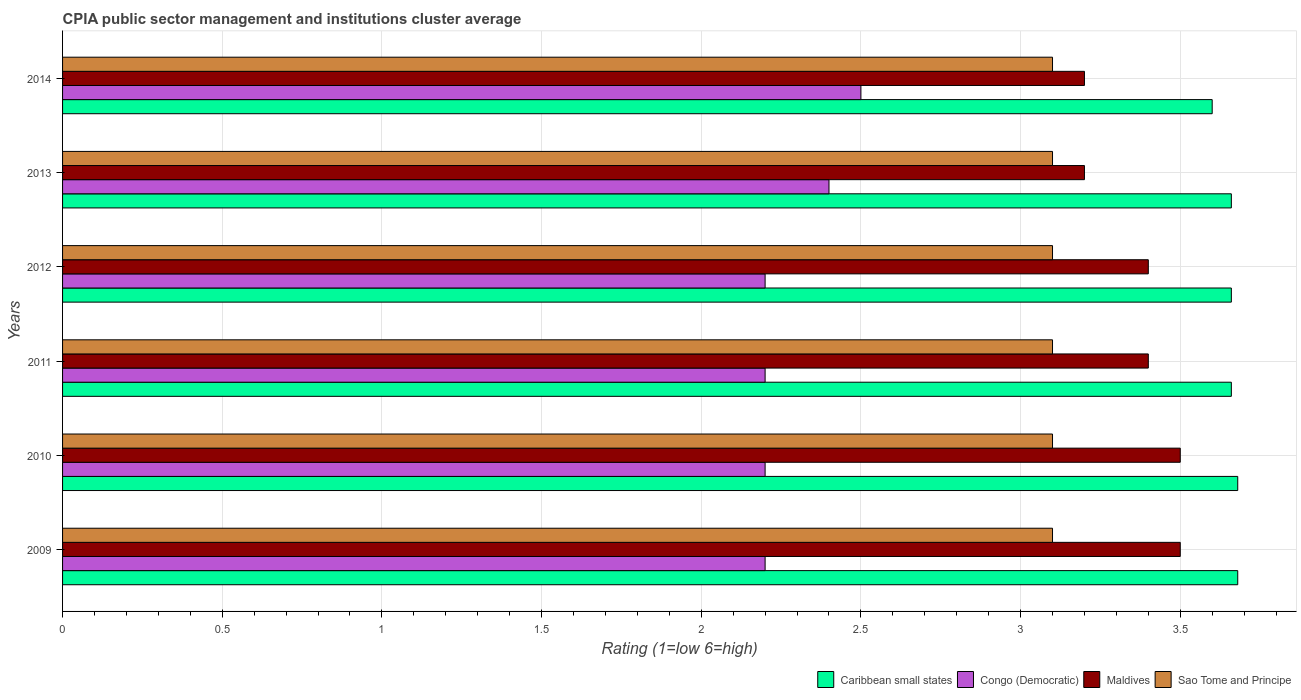Are the number of bars per tick equal to the number of legend labels?
Provide a succinct answer. Yes. How many bars are there on the 2nd tick from the top?
Your answer should be very brief. 4. In how many cases, is the number of bars for a given year not equal to the number of legend labels?
Give a very brief answer. 0. What is the CPIA rating in Caribbean small states in 2010?
Your response must be concise. 3.68. Across all years, what is the minimum CPIA rating in Congo (Democratic)?
Your answer should be very brief. 2.2. In which year was the CPIA rating in Sao Tome and Principe maximum?
Your answer should be compact. 2009. In which year was the CPIA rating in Maldives minimum?
Make the answer very short. 2013. What is the total CPIA rating in Sao Tome and Principe in the graph?
Offer a very short reply. 18.6. What is the difference between the CPIA rating in Caribbean small states in 2011 and that in 2012?
Offer a very short reply. 0. What is the difference between the CPIA rating in Maldives in 2009 and the CPIA rating in Caribbean small states in 2012?
Your response must be concise. -0.16. What is the average CPIA rating in Maldives per year?
Provide a succinct answer. 3.37. In the year 2009, what is the difference between the CPIA rating in Maldives and CPIA rating in Sao Tome and Principe?
Provide a succinct answer. 0.4. In how many years, is the CPIA rating in Maldives greater than 0.9 ?
Give a very brief answer. 6. What is the ratio of the CPIA rating in Maldives in 2010 to that in 2013?
Your response must be concise. 1.09. Is the CPIA rating in Sao Tome and Principe in 2012 less than that in 2014?
Offer a terse response. No. Is the difference between the CPIA rating in Maldives in 2009 and 2013 greater than the difference between the CPIA rating in Sao Tome and Principe in 2009 and 2013?
Your answer should be very brief. Yes. What is the difference between the highest and the lowest CPIA rating in Sao Tome and Principe?
Your answer should be compact. 0. In how many years, is the CPIA rating in Congo (Democratic) greater than the average CPIA rating in Congo (Democratic) taken over all years?
Offer a terse response. 2. Is the sum of the CPIA rating in Sao Tome and Principe in 2010 and 2011 greater than the maximum CPIA rating in Congo (Democratic) across all years?
Ensure brevity in your answer.  Yes. What does the 4th bar from the top in 2009 represents?
Your answer should be very brief. Caribbean small states. What does the 3rd bar from the bottom in 2009 represents?
Keep it short and to the point. Maldives. Is it the case that in every year, the sum of the CPIA rating in Caribbean small states and CPIA rating in Maldives is greater than the CPIA rating in Sao Tome and Principe?
Provide a succinct answer. Yes. How many years are there in the graph?
Keep it short and to the point. 6. What is the difference between two consecutive major ticks on the X-axis?
Keep it short and to the point. 0.5. Are the values on the major ticks of X-axis written in scientific E-notation?
Your answer should be compact. No. Does the graph contain any zero values?
Make the answer very short. No. How are the legend labels stacked?
Your answer should be compact. Horizontal. What is the title of the graph?
Offer a very short reply. CPIA public sector management and institutions cluster average. Does "Mozambique" appear as one of the legend labels in the graph?
Make the answer very short. No. What is the label or title of the X-axis?
Offer a terse response. Rating (1=low 6=high). What is the Rating (1=low 6=high) in Caribbean small states in 2009?
Offer a terse response. 3.68. What is the Rating (1=low 6=high) in Congo (Democratic) in 2009?
Keep it short and to the point. 2.2. What is the Rating (1=low 6=high) of Maldives in 2009?
Your response must be concise. 3.5. What is the Rating (1=low 6=high) in Caribbean small states in 2010?
Make the answer very short. 3.68. What is the Rating (1=low 6=high) in Maldives in 2010?
Provide a succinct answer. 3.5. What is the Rating (1=low 6=high) of Sao Tome and Principe in 2010?
Keep it short and to the point. 3.1. What is the Rating (1=low 6=high) of Caribbean small states in 2011?
Make the answer very short. 3.66. What is the Rating (1=low 6=high) of Congo (Democratic) in 2011?
Give a very brief answer. 2.2. What is the Rating (1=low 6=high) of Maldives in 2011?
Provide a short and direct response. 3.4. What is the Rating (1=low 6=high) of Caribbean small states in 2012?
Offer a terse response. 3.66. What is the Rating (1=low 6=high) of Congo (Democratic) in 2012?
Give a very brief answer. 2.2. What is the Rating (1=low 6=high) in Caribbean small states in 2013?
Your answer should be compact. 3.66. What is the Rating (1=low 6=high) of Congo (Democratic) in 2013?
Your answer should be very brief. 2.4. What is the Rating (1=low 6=high) of Congo (Democratic) in 2014?
Give a very brief answer. 2.5. What is the Rating (1=low 6=high) of Maldives in 2014?
Make the answer very short. 3.2. What is the Rating (1=low 6=high) in Sao Tome and Principe in 2014?
Your answer should be very brief. 3.1. Across all years, what is the maximum Rating (1=low 6=high) of Caribbean small states?
Provide a short and direct response. 3.68. Across all years, what is the maximum Rating (1=low 6=high) in Congo (Democratic)?
Ensure brevity in your answer.  2.5. Across all years, what is the maximum Rating (1=low 6=high) of Sao Tome and Principe?
Make the answer very short. 3.1. Across all years, what is the minimum Rating (1=low 6=high) of Congo (Democratic)?
Ensure brevity in your answer.  2.2. Across all years, what is the minimum Rating (1=low 6=high) in Maldives?
Make the answer very short. 3.2. Across all years, what is the minimum Rating (1=low 6=high) of Sao Tome and Principe?
Keep it short and to the point. 3.1. What is the total Rating (1=low 6=high) of Caribbean small states in the graph?
Offer a very short reply. 21.94. What is the total Rating (1=low 6=high) of Congo (Democratic) in the graph?
Your response must be concise. 13.7. What is the total Rating (1=low 6=high) in Maldives in the graph?
Your answer should be compact. 20.2. What is the difference between the Rating (1=low 6=high) of Caribbean small states in 2009 and that in 2010?
Make the answer very short. 0. What is the difference between the Rating (1=low 6=high) in Congo (Democratic) in 2009 and that in 2010?
Keep it short and to the point. 0. What is the difference between the Rating (1=low 6=high) of Maldives in 2009 and that in 2010?
Offer a terse response. 0. What is the difference between the Rating (1=low 6=high) in Sao Tome and Principe in 2009 and that in 2010?
Your response must be concise. 0. What is the difference between the Rating (1=low 6=high) of Maldives in 2009 and that in 2011?
Make the answer very short. 0.1. What is the difference between the Rating (1=low 6=high) in Congo (Democratic) in 2009 and that in 2012?
Provide a succinct answer. 0. What is the difference between the Rating (1=low 6=high) in Maldives in 2009 and that in 2013?
Provide a short and direct response. 0.3. What is the difference between the Rating (1=low 6=high) of Caribbean small states in 2009 and that in 2014?
Offer a very short reply. 0.08. What is the difference between the Rating (1=low 6=high) in Congo (Democratic) in 2009 and that in 2014?
Your response must be concise. -0.3. What is the difference between the Rating (1=low 6=high) in Maldives in 2009 and that in 2014?
Offer a very short reply. 0.3. What is the difference between the Rating (1=low 6=high) of Congo (Democratic) in 2010 and that in 2011?
Offer a very short reply. 0. What is the difference between the Rating (1=low 6=high) of Sao Tome and Principe in 2010 and that in 2011?
Give a very brief answer. 0. What is the difference between the Rating (1=low 6=high) in Caribbean small states in 2010 and that in 2013?
Give a very brief answer. 0.02. What is the difference between the Rating (1=low 6=high) in Congo (Democratic) in 2010 and that in 2013?
Offer a terse response. -0.2. What is the difference between the Rating (1=low 6=high) of Maldives in 2010 and that in 2013?
Provide a short and direct response. 0.3. What is the difference between the Rating (1=low 6=high) in Caribbean small states in 2010 and that in 2014?
Your answer should be very brief. 0.08. What is the difference between the Rating (1=low 6=high) of Maldives in 2010 and that in 2014?
Your answer should be compact. 0.3. What is the difference between the Rating (1=low 6=high) of Sao Tome and Principe in 2010 and that in 2014?
Keep it short and to the point. 0. What is the difference between the Rating (1=low 6=high) in Congo (Democratic) in 2011 and that in 2013?
Provide a succinct answer. -0.2. What is the difference between the Rating (1=low 6=high) in Caribbean small states in 2011 and that in 2014?
Your answer should be compact. 0.06. What is the difference between the Rating (1=low 6=high) in Congo (Democratic) in 2011 and that in 2014?
Give a very brief answer. -0.3. What is the difference between the Rating (1=low 6=high) in Maldives in 2011 and that in 2014?
Give a very brief answer. 0.2. What is the difference between the Rating (1=low 6=high) in Caribbean small states in 2012 and that in 2013?
Keep it short and to the point. 0. What is the difference between the Rating (1=low 6=high) in Sao Tome and Principe in 2012 and that in 2013?
Your answer should be very brief. 0. What is the difference between the Rating (1=low 6=high) of Caribbean small states in 2012 and that in 2014?
Give a very brief answer. 0.06. What is the difference between the Rating (1=low 6=high) in Congo (Democratic) in 2012 and that in 2014?
Ensure brevity in your answer.  -0.3. What is the difference between the Rating (1=low 6=high) in Maldives in 2012 and that in 2014?
Offer a terse response. 0.2. What is the difference between the Rating (1=low 6=high) in Caribbean small states in 2013 and that in 2014?
Your response must be concise. 0.06. What is the difference between the Rating (1=low 6=high) of Caribbean small states in 2009 and the Rating (1=low 6=high) of Congo (Democratic) in 2010?
Provide a succinct answer. 1.48. What is the difference between the Rating (1=low 6=high) in Caribbean small states in 2009 and the Rating (1=low 6=high) in Maldives in 2010?
Your answer should be very brief. 0.18. What is the difference between the Rating (1=low 6=high) in Caribbean small states in 2009 and the Rating (1=low 6=high) in Sao Tome and Principe in 2010?
Your answer should be very brief. 0.58. What is the difference between the Rating (1=low 6=high) of Congo (Democratic) in 2009 and the Rating (1=low 6=high) of Maldives in 2010?
Your answer should be compact. -1.3. What is the difference between the Rating (1=low 6=high) in Congo (Democratic) in 2009 and the Rating (1=low 6=high) in Sao Tome and Principe in 2010?
Offer a very short reply. -0.9. What is the difference between the Rating (1=low 6=high) of Caribbean small states in 2009 and the Rating (1=low 6=high) of Congo (Democratic) in 2011?
Provide a short and direct response. 1.48. What is the difference between the Rating (1=low 6=high) in Caribbean small states in 2009 and the Rating (1=low 6=high) in Maldives in 2011?
Make the answer very short. 0.28. What is the difference between the Rating (1=low 6=high) of Caribbean small states in 2009 and the Rating (1=low 6=high) of Sao Tome and Principe in 2011?
Offer a terse response. 0.58. What is the difference between the Rating (1=low 6=high) of Congo (Democratic) in 2009 and the Rating (1=low 6=high) of Maldives in 2011?
Provide a succinct answer. -1.2. What is the difference between the Rating (1=low 6=high) in Caribbean small states in 2009 and the Rating (1=low 6=high) in Congo (Democratic) in 2012?
Your response must be concise. 1.48. What is the difference between the Rating (1=low 6=high) of Caribbean small states in 2009 and the Rating (1=low 6=high) of Maldives in 2012?
Give a very brief answer. 0.28. What is the difference between the Rating (1=low 6=high) in Caribbean small states in 2009 and the Rating (1=low 6=high) in Sao Tome and Principe in 2012?
Keep it short and to the point. 0.58. What is the difference between the Rating (1=low 6=high) of Caribbean small states in 2009 and the Rating (1=low 6=high) of Congo (Democratic) in 2013?
Make the answer very short. 1.28. What is the difference between the Rating (1=low 6=high) in Caribbean small states in 2009 and the Rating (1=low 6=high) in Maldives in 2013?
Offer a very short reply. 0.48. What is the difference between the Rating (1=low 6=high) in Caribbean small states in 2009 and the Rating (1=low 6=high) in Sao Tome and Principe in 2013?
Provide a succinct answer. 0.58. What is the difference between the Rating (1=low 6=high) in Congo (Democratic) in 2009 and the Rating (1=low 6=high) in Maldives in 2013?
Provide a short and direct response. -1. What is the difference between the Rating (1=low 6=high) of Congo (Democratic) in 2009 and the Rating (1=low 6=high) of Sao Tome and Principe in 2013?
Your answer should be very brief. -0.9. What is the difference between the Rating (1=low 6=high) of Caribbean small states in 2009 and the Rating (1=low 6=high) of Congo (Democratic) in 2014?
Your answer should be very brief. 1.18. What is the difference between the Rating (1=low 6=high) in Caribbean small states in 2009 and the Rating (1=low 6=high) in Maldives in 2014?
Give a very brief answer. 0.48. What is the difference between the Rating (1=low 6=high) in Caribbean small states in 2009 and the Rating (1=low 6=high) in Sao Tome and Principe in 2014?
Make the answer very short. 0.58. What is the difference between the Rating (1=low 6=high) of Maldives in 2009 and the Rating (1=low 6=high) of Sao Tome and Principe in 2014?
Offer a terse response. 0.4. What is the difference between the Rating (1=low 6=high) in Caribbean small states in 2010 and the Rating (1=low 6=high) in Congo (Democratic) in 2011?
Ensure brevity in your answer.  1.48. What is the difference between the Rating (1=low 6=high) in Caribbean small states in 2010 and the Rating (1=low 6=high) in Maldives in 2011?
Provide a succinct answer. 0.28. What is the difference between the Rating (1=low 6=high) of Caribbean small states in 2010 and the Rating (1=low 6=high) of Sao Tome and Principe in 2011?
Make the answer very short. 0.58. What is the difference between the Rating (1=low 6=high) in Maldives in 2010 and the Rating (1=low 6=high) in Sao Tome and Principe in 2011?
Offer a terse response. 0.4. What is the difference between the Rating (1=low 6=high) of Caribbean small states in 2010 and the Rating (1=low 6=high) of Congo (Democratic) in 2012?
Make the answer very short. 1.48. What is the difference between the Rating (1=low 6=high) in Caribbean small states in 2010 and the Rating (1=low 6=high) in Maldives in 2012?
Provide a succinct answer. 0.28. What is the difference between the Rating (1=low 6=high) of Caribbean small states in 2010 and the Rating (1=low 6=high) of Sao Tome and Principe in 2012?
Give a very brief answer. 0.58. What is the difference between the Rating (1=low 6=high) in Congo (Democratic) in 2010 and the Rating (1=low 6=high) in Maldives in 2012?
Offer a terse response. -1.2. What is the difference between the Rating (1=low 6=high) of Caribbean small states in 2010 and the Rating (1=low 6=high) of Congo (Democratic) in 2013?
Keep it short and to the point. 1.28. What is the difference between the Rating (1=low 6=high) of Caribbean small states in 2010 and the Rating (1=low 6=high) of Maldives in 2013?
Make the answer very short. 0.48. What is the difference between the Rating (1=low 6=high) of Caribbean small states in 2010 and the Rating (1=low 6=high) of Sao Tome and Principe in 2013?
Make the answer very short. 0.58. What is the difference between the Rating (1=low 6=high) of Congo (Democratic) in 2010 and the Rating (1=low 6=high) of Maldives in 2013?
Offer a very short reply. -1. What is the difference between the Rating (1=low 6=high) of Maldives in 2010 and the Rating (1=low 6=high) of Sao Tome and Principe in 2013?
Offer a terse response. 0.4. What is the difference between the Rating (1=low 6=high) in Caribbean small states in 2010 and the Rating (1=low 6=high) in Congo (Democratic) in 2014?
Your answer should be compact. 1.18. What is the difference between the Rating (1=low 6=high) in Caribbean small states in 2010 and the Rating (1=low 6=high) in Maldives in 2014?
Your response must be concise. 0.48. What is the difference between the Rating (1=low 6=high) in Caribbean small states in 2010 and the Rating (1=low 6=high) in Sao Tome and Principe in 2014?
Ensure brevity in your answer.  0.58. What is the difference between the Rating (1=low 6=high) in Congo (Democratic) in 2010 and the Rating (1=low 6=high) in Sao Tome and Principe in 2014?
Offer a very short reply. -0.9. What is the difference between the Rating (1=low 6=high) of Caribbean small states in 2011 and the Rating (1=low 6=high) of Congo (Democratic) in 2012?
Give a very brief answer. 1.46. What is the difference between the Rating (1=low 6=high) in Caribbean small states in 2011 and the Rating (1=low 6=high) in Maldives in 2012?
Your answer should be compact. 0.26. What is the difference between the Rating (1=low 6=high) of Caribbean small states in 2011 and the Rating (1=low 6=high) of Sao Tome and Principe in 2012?
Keep it short and to the point. 0.56. What is the difference between the Rating (1=low 6=high) in Maldives in 2011 and the Rating (1=low 6=high) in Sao Tome and Principe in 2012?
Provide a short and direct response. 0.3. What is the difference between the Rating (1=low 6=high) of Caribbean small states in 2011 and the Rating (1=low 6=high) of Congo (Democratic) in 2013?
Give a very brief answer. 1.26. What is the difference between the Rating (1=low 6=high) in Caribbean small states in 2011 and the Rating (1=low 6=high) in Maldives in 2013?
Your answer should be very brief. 0.46. What is the difference between the Rating (1=low 6=high) of Caribbean small states in 2011 and the Rating (1=low 6=high) of Sao Tome and Principe in 2013?
Give a very brief answer. 0.56. What is the difference between the Rating (1=low 6=high) of Congo (Democratic) in 2011 and the Rating (1=low 6=high) of Maldives in 2013?
Your response must be concise. -1. What is the difference between the Rating (1=low 6=high) in Caribbean small states in 2011 and the Rating (1=low 6=high) in Congo (Democratic) in 2014?
Your response must be concise. 1.16. What is the difference between the Rating (1=low 6=high) in Caribbean small states in 2011 and the Rating (1=low 6=high) in Maldives in 2014?
Your answer should be very brief. 0.46. What is the difference between the Rating (1=low 6=high) in Caribbean small states in 2011 and the Rating (1=low 6=high) in Sao Tome and Principe in 2014?
Your answer should be compact. 0.56. What is the difference between the Rating (1=low 6=high) in Maldives in 2011 and the Rating (1=low 6=high) in Sao Tome and Principe in 2014?
Keep it short and to the point. 0.3. What is the difference between the Rating (1=low 6=high) of Caribbean small states in 2012 and the Rating (1=low 6=high) of Congo (Democratic) in 2013?
Offer a very short reply. 1.26. What is the difference between the Rating (1=low 6=high) of Caribbean small states in 2012 and the Rating (1=low 6=high) of Maldives in 2013?
Offer a very short reply. 0.46. What is the difference between the Rating (1=low 6=high) of Caribbean small states in 2012 and the Rating (1=low 6=high) of Sao Tome and Principe in 2013?
Your answer should be very brief. 0.56. What is the difference between the Rating (1=low 6=high) of Congo (Democratic) in 2012 and the Rating (1=low 6=high) of Maldives in 2013?
Offer a terse response. -1. What is the difference between the Rating (1=low 6=high) of Caribbean small states in 2012 and the Rating (1=low 6=high) of Congo (Democratic) in 2014?
Make the answer very short. 1.16. What is the difference between the Rating (1=low 6=high) of Caribbean small states in 2012 and the Rating (1=low 6=high) of Maldives in 2014?
Provide a short and direct response. 0.46. What is the difference between the Rating (1=low 6=high) of Caribbean small states in 2012 and the Rating (1=low 6=high) of Sao Tome and Principe in 2014?
Make the answer very short. 0.56. What is the difference between the Rating (1=low 6=high) of Congo (Democratic) in 2012 and the Rating (1=low 6=high) of Sao Tome and Principe in 2014?
Keep it short and to the point. -0.9. What is the difference between the Rating (1=low 6=high) of Caribbean small states in 2013 and the Rating (1=low 6=high) of Congo (Democratic) in 2014?
Your answer should be compact. 1.16. What is the difference between the Rating (1=low 6=high) of Caribbean small states in 2013 and the Rating (1=low 6=high) of Maldives in 2014?
Your answer should be very brief. 0.46. What is the difference between the Rating (1=low 6=high) of Caribbean small states in 2013 and the Rating (1=low 6=high) of Sao Tome and Principe in 2014?
Provide a short and direct response. 0.56. What is the difference between the Rating (1=low 6=high) in Congo (Democratic) in 2013 and the Rating (1=low 6=high) in Maldives in 2014?
Your answer should be very brief. -0.8. What is the difference between the Rating (1=low 6=high) in Congo (Democratic) in 2013 and the Rating (1=low 6=high) in Sao Tome and Principe in 2014?
Provide a succinct answer. -0.7. What is the average Rating (1=low 6=high) in Caribbean small states per year?
Keep it short and to the point. 3.66. What is the average Rating (1=low 6=high) in Congo (Democratic) per year?
Provide a short and direct response. 2.28. What is the average Rating (1=low 6=high) of Maldives per year?
Make the answer very short. 3.37. What is the average Rating (1=low 6=high) in Sao Tome and Principe per year?
Offer a terse response. 3.1. In the year 2009, what is the difference between the Rating (1=low 6=high) of Caribbean small states and Rating (1=low 6=high) of Congo (Democratic)?
Your response must be concise. 1.48. In the year 2009, what is the difference between the Rating (1=low 6=high) in Caribbean small states and Rating (1=low 6=high) in Maldives?
Offer a terse response. 0.18. In the year 2009, what is the difference between the Rating (1=low 6=high) in Caribbean small states and Rating (1=low 6=high) in Sao Tome and Principe?
Keep it short and to the point. 0.58. In the year 2009, what is the difference between the Rating (1=low 6=high) of Congo (Democratic) and Rating (1=low 6=high) of Maldives?
Keep it short and to the point. -1.3. In the year 2009, what is the difference between the Rating (1=low 6=high) in Congo (Democratic) and Rating (1=low 6=high) in Sao Tome and Principe?
Your answer should be compact. -0.9. In the year 2010, what is the difference between the Rating (1=low 6=high) in Caribbean small states and Rating (1=low 6=high) in Congo (Democratic)?
Your answer should be very brief. 1.48. In the year 2010, what is the difference between the Rating (1=low 6=high) of Caribbean small states and Rating (1=low 6=high) of Maldives?
Keep it short and to the point. 0.18. In the year 2010, what is the difference between the Rating (1=low 6=high) of Caribbean small states and Rating (1=low 6=high) of Sao Tome and Principe?
Provide a short and direct response. 0.58. In the year 2010, what is the difference between the Rating (1=low 6=high) in Congo (Democratic) and Rating (1=low 6=high) in Maldives?
Provide a succinct answer. -1.3. In the year 2011, what is the difference between the Rating (1=low 6=high) of Caribbean small states and Rating (1=low 6=high) of Congo (Democratic)?
Offer a terse response. 1.46. In the year 2011, what is the difference between the Rating (1=low 6=high) of Caribbean small states and Rating (1=low 6=high) of Maldives?
Provide a short and direct response. 0.26. In the year 2011, what is the difference between the Rating (1=low 6=high) of Caribbean small states and Rating (1=low 6=high) of Sao Tome and Principe?
Offer a terse response. 0.56. In the year 2011, what is the difference between the Rating (1=low 6=high) of Congo (Democratic) and Rating (1=low 6=high) of Maldives?
Make the answer very short. -1.2. In the year 2011, what is the difference between the Rating (1=low 6=high) in Congo (Democratic) and Rating (1=low 6=high) in Sao Tome and Principe?
Provide a succinct answer. -0.9. In the year 2011, what is the difference between the Rating (1=low 6=high) of Maldives and Rating (1=low 6=high) of Sao Tome and Principe?
Provide a short and direct response. 0.3. In the year 2012, what is the difference between the Rating (1=low 6=high) in Caribbean small states and Rating (1=low 6=high) in Congo (Democratic)?
Ensure brevity in your answer.  1.46. In the year 2012, what is the difference between the Rating (1=low 6=high) of Caribbean small states and Rating (1=low 6=high) of Maldives?
Offer a terse response. 0.26. In the year 2012, what is the difference between the Rating (1=low 6=high) in Caribbean small states and Rating (1=low 6=high) in Sao Tome and Principe?
Provide a short and direct response. 0.56. In the year 2012, what is the difference between the Rating (1=low 6=high) in Congo (Democratic) and Rating (1=low 6=high) in Maldives?
Provide a succinct answer. -1.2. In the year 2012, what is the difference between the Rating (1=low 6=high) in Congo (Democratic) and Rating (1=low 6=high) in Sao Tome and Principe?
Offer a terse response. -0.9. In the year 2012, what is the difference between the Rating (1=low 6=high) in Maldives and Rating (1=low 6=high) in Sao Tome and Principe?
Keep it short and to the point. 0.3. In the year 2013, what is the difference between the Rating (1=low 6=high) in Caribbean small states and Rating (1=low 6=high) in Congo (Democratic)?
Your answer should be very brief. 1.26. In the year 2013, what is the difference between the Rating (1=low 6=high) in Caribbean small states and Rating (1=low 6=high) in Maldives?
Provide a succinct answer. 0.46. In the year 2013, what is the difference between the Rating (1=low 6=high) in Caribbean small states and Rating (1=low 6=high) in Sao Tome and Principe?
Your answer should be very brief. 0.56. In the year 2013, what is the difference between the Rating (1=low 6=high) of Congo (Democratic) and Rating (1=low 6=high) of Maldives?
Provide a succinct answer. -0.8. In the year 2013, what is the difference between the Rating (1=low 6=high) of Congo (Democratic) and Rating (1=low 6=high) of Sao Tome and Principe?
Make the answer very short. -0.7. In the year 2014, what is the difference between the Rating (1=low 6=high) of Caribbean small states and Rating (1=low 6=high) of Congo (Democratic)?
Offer a terse response. 1.1. In the year 2014, what is the difference between the Rating (1=low 6=high) in Caribbean small states and Rating (1=low 6=high) in Sao Tome and Principe?
Make the answer very short. 0.5. In the year 2014, what is the difference between the Rating (1=low 6=high) of Congo (Democratic) and Rating (1=low 6=high) of Maldives?
Offer a very short reply. -0.7. In the year 2014, what is the difference between the Rating (1=low 6=high) of Congo (Democratic) and Rating (1=low 6=high) of Sao Tome and Principe?
Offer a very short reply. -0.6. What is the ratio of the Rating (1=low 6=high) in Caribbean small states in 2009 to that in 2010?
Your answer should be compact. 1. What is the ratio of the Rating (1=low 6=high) of Congo (Democratic) in 2009 to that in 2010?
Offer a terse response. 1. What is the ratio of the Rating (1=low 6=high) in Maldives in 2009 to that in 2010?
Offer a terse response. 1. What is the ratio of the Rating (1=low 6=high) of Sao Tome and Principe in 2009 to that in 2010?
Provide a succinct answer. 1. What is the ratio of the Rating (1=low 6=high) of Maldives in 2009 to that in 2011?
Offer a very short reply. 1.03. What is the ratio of the Rating (1=low 6=high) of Caribbean small states in 2009 to that in 2012?
Your answer should be very brief. 1.01. What is the ratio of the Rating (1=low 6=high) in Congo (Democratic) in 2009 to that in 2012?
Provide a short and direct response. 1. What is the ratio of the Rating (1=low 6=high) in Maldives in 2009 to that in 2012?
Your response must be concise. 1.03. What is the ratio of the Rating (1=low 6=high) in Sao Tome and Principe in 2009 to that in 2012?
Your response must be concise. 1. What is the ratio of the Rating (1=low 6=high) in Maldives in 2009 to that in 2013?
Your response must be concise. 1.09. What is the ratio of the Rating (1=low 6=high) in Caribbean small states in 2009 to that in 2014?
Provide a short and direct response. 1.02. What is the ratio of the Rating (1=low 6=high) in Maldives in 2009 to that in 2014?
Provide a short and direct response. 1.09. What is the ratio of the Rating (1=low 6=high) of Caribbean small states in 2010 to that in 2011?
Offer a very short reply. 1.01. What is the ratio of the Rating (1=low 6=high) in Congo (Democratic) in 2010 to that in 2011?
Your answer should be compact. 1. What is the ratio of the Rating (1=low 6=high) of Maldives in 2010 to that in 2011?
Your response must be concise. 1.03. What is the ratio of the Rating (1=low 6=high) of Sao Tome and Principe in 2010 to that in 2011?
Keep it short and to the point. 1. What is the ratio of the Rating (1=low 6=high) in Congo (Democratic) in 2010 to that in 2012?
Provide a short and direct response. 1. What is the ratio of the Rating (1=low 6=high) in Maldives in 2010 to that in 2012?
Provide a short and direct response. 1.03. What is the ratio of the Rating (1=low 6=high) of Sao Tome and Principe in 2010 to that in 2012?
Your response must be concise. 1. What is the ratio of the Rating (1=low 6=high) in Caribbean small states in 2010 to that in 2013?
Ensure brevity in your answer.  1.01. What is the ratio of the Rating (1=low 6=high) in Congo (Democratic) in 2010 to that in 2013?
Provide a short and direct response. 0.92. What is the ratio of the Rating (1=low 6=high) of Maldives in 2010 to that in 2013?
Make the answer very short. 1.09. What is the ratio of the Rating (1=low 6=high) in Sao Tome and Principe in 2010 to that in 2013?
Your answer should be compact. 1. What is the ratio of the Rating (1=low 6=high) of Caribbean small states in 2010 to that in 2014?
Your answer should be very brief. 1.02. What is the ratio of the Rating (1=low 6=high) of Congo (Democratic) in 2010 to that in 2014?
Make the answer very short. 0.88. What is the ratio of the Rating (1=low 6=high) in Maldives in 2010 to that in 2014?
Keep it short and to the point. 1.09. What is the ratio of the Rating (1=low 6=high) in Sao Tome and Principe in 2010 to that in 2014?
Offer a terse response. 1. What is the ratio of the Rating (1=low 6=high) in Caribbean small states in 2011 to that in 2012?
Offer a very short reply. 1. What is the ratio of the Rating (1=low 6=high) of Sao Tome and Principe in 2011 to that in 2012?
Your answer should be compact. 1. What is the ratio of the Rating (1=low 6=high) in Caribbean small states in 2011 to that in 2013?
Your answer should be very brief. 1. What is the ratio of the Rating (1=low 6=high) in Maldives in 2011 to that in 2013?
Provide a short and direct response. 1.06. What is the ratio of the Rating (1=low 6=high) of Sao Tome and Principe in 2011 to that in 2013?
Make the answer very short. 1. What is the ratio of the Rating (1=low 6=high) in Caribbean small states in 2011 to that in 2014?
Your answer should be compact. 1.02. What is the ratio of the Rating (1=low 6=high) in Congo (Democratic) in 2011 to that in 2014?
Offer a very short reply. 0.88. What is the ratio of the Rating (1=low 6=high) of Maldives in 2011 to that in 2014?
Your response must be concise. 1.06. What is the ratio of the Rating (1=low 6=high) in Congo (Democratic) in 2012 to that in 2013?
Make the answer very short. 0.92. What is the ratio of the Rating (1=low 6=high) of Maldives in 2012 to that in 2013?
Offer a very short reply. 1.06. What is the ratio of the Rating (1=low 6=high) of Caribbean small states in 2012 to that in 2014?
Your response must be concise. 1.02. What is the ratio of the Rating (1=low 6=high) of Maldives in 2012 to that in 2014?
Give a very brief answer. 1.06. What is the ratio of the Rating (1=low 6=high) of Caribbean small states in 2013 to that in 2014?
Your answer should be compact. 1.02. What is the ratio of the Rating (1=low 6=high) in Sao Tome and Principe in 2013 to that in 2014?
Provide a short and direct response. 1. What is the difference between the highest and the second highest Rating (1=low 6=high) of Caribbean small states?
Your answer should be compact. 0. What is the difference between the highest and the second highest Rating (1=low 6=high) in Maldives?
Offer a terse response. 0. What is the difference between the highest and the lowest Rating (1=low 6=high) of Caribbean small states?
Provide a succinct answer. 0.08. What is the difference between the highest and the lowest Rating (1=low 6=high) in Maldives?
Ensure brevity in your answer.  0.3. What is the difference between the highest and the lowest Rating (1=low 6=high) in Sao Tome and Principe?
Provide a succinct answer. 0. 